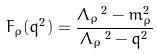Convert formula to latex. <formula><loc_0><loc_0><loc_500><loc_500>F _ { \rho } ( q ^ { 2 } ) = \frac { \Lambda _ { \rho } \, ^ { 2 } - m _ { \rho } ^ { 2 } } { \Lambda _ { \rho } \, ^ { 2 } - q ^ { 2 } }</formula> 